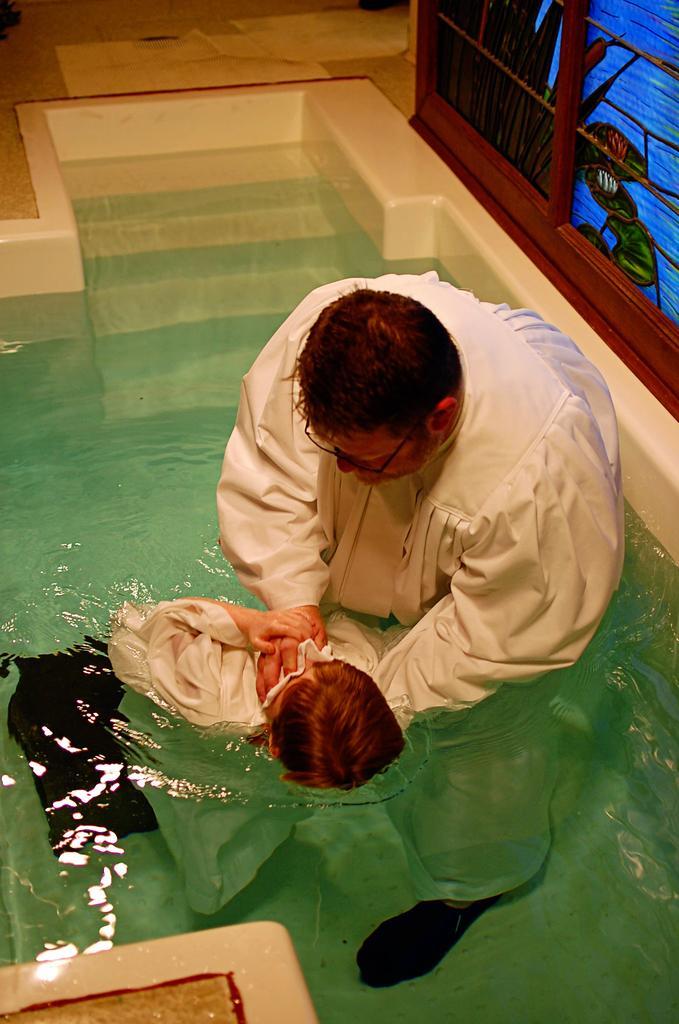In one or two sentences, can you explain what this image depicts? Here in this picture we can see a person in a white colored dress standing in a pool, which is filled with water over there and dipping a person in the water and behind him we can see a wall with a different design present over there. 